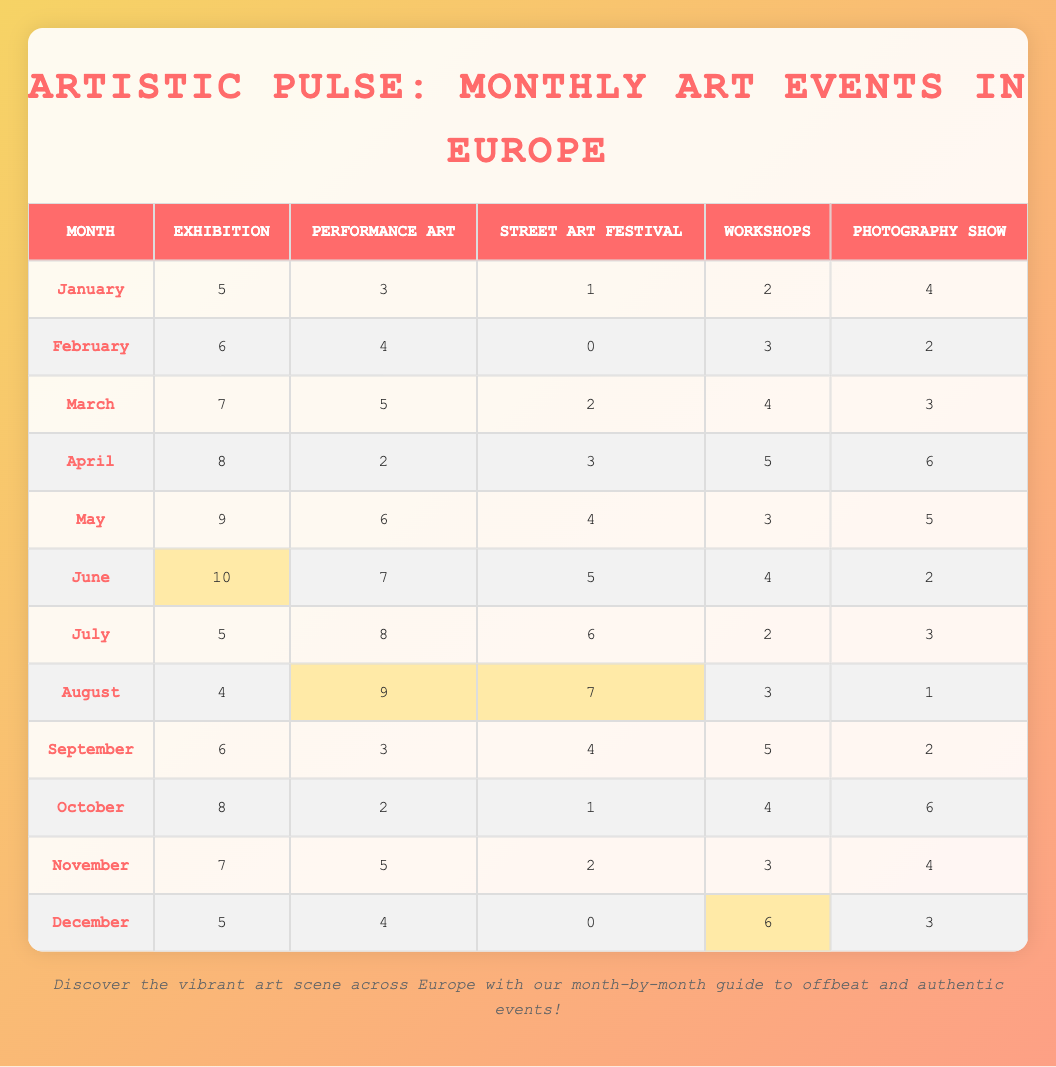What is the total number of Art Events in June? To find the total number of Art Events in June, we need to add the values for each art style in that month: Exhibition (10) + Performance Art (7) + Street Art Festival (5) + Workshops (4) + Photography Show (2). This gives us a total of 10 + 7 + 5 + 4 + 2 = 28.
Answer: 28 In which month did the highest number of Performance Art events occur? By examining the column for Performance Art, we find that the month with the highest value is August with 9 events, as all other months have fewer than 9.
Answer: August What is the average number of Workshops held in the year? We will find the average by summing the values for Workshops across all months and then dividing by the number of months. The sum of Workshops is 2 + 3 + 4 + 5 + 3 + 4 + 2 + 3 + 5 + 4 + 3 + 6 = 54. There are 12 months, so the average is 54 / 12 = 4.5.
Answer: 4.5 Did the Street Art Festival occur in February? Looking at the values for Street Art Festival under February, we see it is 0, indicating there were no events. Thus, the answer is no.
Answer: No Which month had the least number of Exhibitions? By reviewing the values for Exhibitions, we find January has the least with 5 events.
Answer: January 